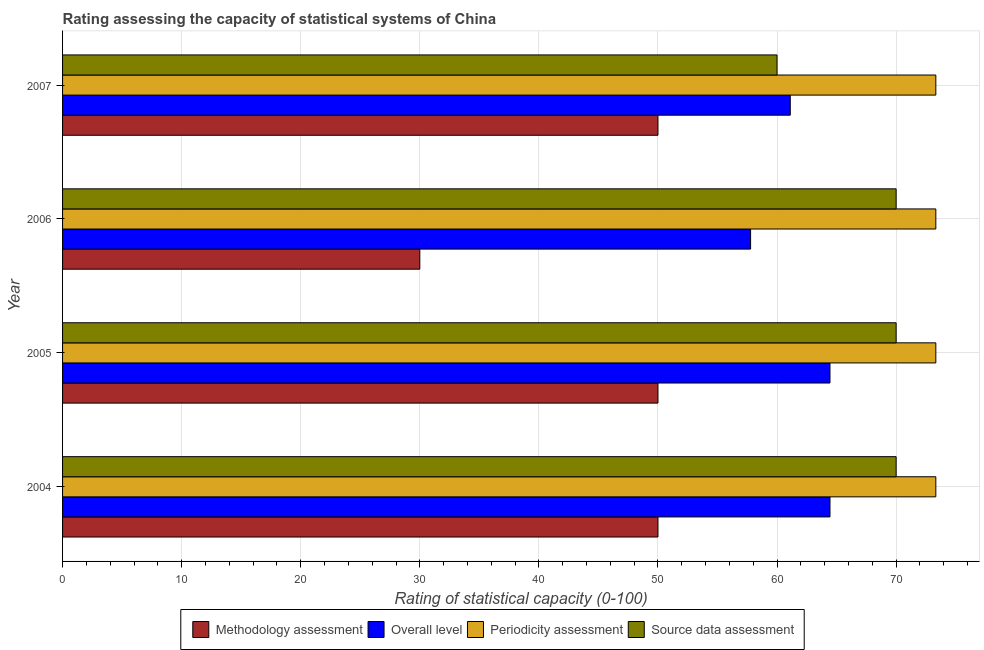How many different coloured bars are there?
Ensure brevity in your answer.  4. How many groups of bars are there?
Offer a very short reply. 4. Are the number of bars on each tick of the Y-axis equal?
Make the answer very short. Yes. How many bars are there on the 1st tick from the top?
Your response must be concise. 4. How many bars are there on the 1st tick from the bottom?
Give a very brief answer. 4. In how many cases, is the number of bars for a given year not equal to the number of legend labels?
Offer a terse response. 0. What is the methodology assessment rating in 2005?
Offer a very short reply. 50. Across all years, what is the maximum overall level rating?
Your answer should be very brief. 64.44. Across all years, what is the minimum source data assessment rating?
Your response must be concise. 60. What is the total overall level rating in the graph?
Provide a succinct answer. 247.78. What is the difference between the overall level rating in 2004 and the source data assessment rating in 2006?
Offer a terse response. -5.56. What is the average overall level rating per year?
Provide a short and direct response. 61.94. In the year 2007, what is the difference between the periodicity assessment rating and source data assessment rating?
Keep it short and to the point. 13.33. What is the ratio of the methodology assessment rating in 2005 to that in 2006?
Provide a short and direct response. 1.67. Is the overall level rating in 2004 less than that in 2007?
Offer a very short reply. No. Is the difference between the source data assessment rating in 2005 and 2006 greater than the difference between the methodology assessment rating in 2005 and 2006?
Make the answer very short. No. What is the difference between the highest and the second highest overall level rating?
Provide a short and direct response. 0. What is the difference between the highest and the lowest methodology assessment rating?
Your answer should be compact. 20. Is the sum of the periodicity assessment rating in 2004 and 2006 greater than the maximum source data assessment rating across all years?
Make the answer very short. Yes. Is it the case that in every year, the sum of the source data assessment rating and overall level rating is greater than the sum of periodicity assessment rating and methodology assessment rating?
Give a very brief answer. Yes. What does the 2nd bar from the top in 2005 represents?
Provide a succinct answer. Periodicity assessment. What does the 3rd bar from the bottom in 2005 represents?
Your answer should be very brief. Periodicity assessment. How many years are there in the graph?
Provide a succinct answer. 4. Are the values on the major ticks of X-axis written in scientific E-notation?
Your answer should be compact. No. Does the graph contain any zero values?
Keep it short and to the point. No. Where does the legend appear in the graph?
Your answer should be very brief. Bottom center. What is the title of the graph?
Offer a terse response. Rating assessing the capacity of statistical systems of China. What is the label or title of the X-axis?
Your answer should be very brief. Rating of statistical capacity (0-100). What is the label or title of the Y-axis?
Give a very brief answer. Year. What is the Rating of statistical capacity (0-100) in Methodology assessment in 2004?
Your answer should be compact. 50. What is the Rating of statistical capacity (0-100) in Overall level in 2004?
Give a very brief answer. 64.44. What is the Rating of statistical capacity (0-100) in Periodicity assessment in 2004?
Provide a succinct answer. 73.33. What is the Rating of statistical capacity (0-100) of Source data assessment in 2004?
Your response must be concise. 70. What is the Rating of statistical capacity (0-100) in Overall level in 2005?
Keep it short and to the point. 64.44. What is the Rating of statistical capacity (0-100) of Periodicity assessment in 2005?
Offer a very short reply. 73.33. What is the Rating of statistical capacity (0-100) of Methodology assessment in 2006?
Give a very brief answer. 30. What is the Rating of statistical capacity (0-100) in Overall level in 2006?
Make the answer very short. 57.78. What is the Rating of statistical capacity (0-100) in Periodicity assessment in 2006?
Keep it short and to the point. 73.33. What is the Rating of statistical capacity (0-100) in Source data assessment in 2006?
Give a very brief answer. 70. What is the Rating of statistical capacity (0-100) in Overall level in 2007?
Make the answer very short. 61.11. What is the Rating of statistical capacity (0-100) of Periodicity assessment in 2007?
Your answer should be compact. 73.33. Across all years, what is the maximum Rating of statistical capacity (0-100) in Methodology assessment?
Give a very brief answer. 50. Across all years, what is the maximum Rating of statistical capacity (0-100) of Overall level?
Your answer should be compact. 64.44. Across all years, what is the maximum Rating of statistical capacity (0-100) in Periodicity assessment?
Provide a short and direct response. 73.33. Across all years, what is the maximum Rating of statistical capacity (0-100) in Source data assessment?
Give a very brief answer. 70. Across all years, what is the minimum Rating of statistical capacity (0-100) of Methodology assessment?
Offer a terse response. 30. Across all years, what is the minimum Rating of statistical capacity (0-100) in Overall level?
Offer a very short reply. 57.78. Across all years, what is the minimum Rating of statistical capacity (0-100) of Periodicity assessment?
Provide a short and direct response. 73.33. What is the total Rating of statistical capacity (0-100) of Methodology assessment in the graph?
Your answer should be very brief. 180. What is the total Rating of statistical capacity (0-100) in Overall level in the graph?
Keep it short and to the point. 247.78. What is the total Rating of statistical capacity (0-100) of Periodicity assessment in the graph?
Provide a succinct answer. 293.33. What is the total Rating of statistical capacity (0-100) of Source data assessment in the graph?
Keep it short and to the point. 270. What is the difference between the Rating of statistical capacity (0-100) in Methodology assessment in 2004 and that in 2005?
Offer a terse response. 0. What is the difference between the Rating of statistical capacity (0-100) of Overall level in 2004 and that in 2005?
Make the answer very short. 0. What is the difference between the Rating of statistical capacity (0-100) of Periodicity assessment in 2004 and that in 2005?
Provide a short and direct response. 0. What is the difference between the Rating of statistical capacity (0-100) in Source data assessment in 2004 and that in 2005?
Offer a very short reply. 0. What is the difference between the Rating of statistical capacity (0-100) in Overall level in 2004 and that in 2006?
Give a very brief answer. 6.67. What is the difference between the Rating of statistical capacity (0-100) of Source data assessment in 2004 and that in 2007?
Your answer should be very brief. 10. What is the difference between the Rating of statistical capacity (0-100) of Methodology assessment in 2005 and that in 2006?
Keep it short and to the point. 20. What is the difference between the Rating of statistical capacity (0-100) in Overall level in 2005 and that in 2006?
Your answer should be very brief. 6.67. What is the difference between the Rating of statistical capacity (0-100) of Source data assessment in 2005 and that in 2006?
Your response must be concise. 0. What is the difference between the Rating of statistical capacity (0-100) in Methodology assessment in 2006 and that in 2007?
Your answer should be compact. -20. What is the difference between the Rating of statistical capacity (0-100) of Overall level in 2006 and that in 2007?
Offer a terse response. -3.33. What is the difference between the Rating of statistical capacity (0-100) in Periodicity assessment in 2006 and that in 2007?
Your answer should be compact. 0. What is the difference between the Rating of statistical capacity (0-100) in Methodology assessment in 2004 and the Rating of statistical capacity (0-100) in Overall level in 2005?
Offer a very short reply. -14.44. What is the difference between the Rating of statistical capacity (0-100) in Methodology assessment in 2004 and the Rating of statistical capacity (0-100) in Periodicity assessment in 2005?
Provide a succinct answer. -23.33. What is the difference between the Rating of statistical capacity (0-100) of Overall level in 2004 and the Rating of statistical capacity (0-100) of Periodicity assessment in 2005?
Give a very brief answer. -8.89. What is the difference between the Rating of statistical capacity (0-100) of Overall level in 2004 and the Rating of statistical capacity (0-100) of Source data assessment in 2005?
Offer a very short reply. -5.56. What is the difference between the Rating of statistical capacity (0-100) in Methodology assessment in 2004 and the Rating of statistical capacity (0-100) in Overall level in 2006?
Offer a very short reply. -7.78. What is the difference between the Rating of statistical capacity (0-100) in Methodology assessment in 2004 and the Rating of statistical capacity (0-100) in Periodicity assessment in 2006?
Your response must be concise. -23.33. What is the difference between the Rating of statistical capacity (0-100) in Overall level in 2004 and the Rating of statistical capacity (0-100) in Periodicity assessment in 2006?
Provide a short and direct response. -8.89. What is the difference between the Rating of statistical capacity (0-100) in Overall level in 2004 and the Rating of statistical capacity (0-100) in Source data assessment in 2006?
Keep it short and to the point. -5.56. What is the difference between the Rating of statistical capacity (0-100) of Periodicity assessment in 2004 and the Rating of statistical capacity (0-100) of Source data assessment in 2006?
Your answer should be very brief. 3.33. What is the difference between the Rating of statistical capacity (0-100) in Methodology assessment in 2004 and the Rating of statistical capacity (0-100) in Overall level in 2007?
Provide a short and direct response. -11.11. What is the difference between the Rating of statistical capacity (0-100) of Methodology assessment in 2004 and the Rating of statistical capacity (0-100) of Periodicity assessment in 2007?
Keep it short and to the point. -23.33. What is the difference between the Rating of statistical capacity (0-100) of Methodology assessment in 2004 and the Rating of statistical capacity (0-100) of Source data assessment in 2007?
Provide a succinct answer. -10. What is the difference between the Rating of statistical capacity (0-100) of Overall level in 2004 and the Rating of statistical capacity (0-100) of Periodicity assessment in 2007?
Offer a terse response. -8.89. What is the difference between the Rating of statistical capacity (0-100) of Overall level in 2004 and the Rating of statistical capacity (0-100) of Source data assessment in 2007?
Make the answer very short. 4.44. What is the difference between the Rating of statistical capacity (0-100) of Periodicity assessment in 2004 and the Rating of statistical capacity (0-100) of Source data assessment in 2007?
Provide a short and direct response. 13.33. What is the difference between the Rating of statistical capacity (0-100) of Methodology assessment in 2005 and the Rating of statistical capacity (0-100) of Overall level in 2006?
Your answer should be very brief. -7.78. What is the difference between the Rating of statistical capacity (0-100) in Methodology assessment in 2005 and the Rating of statistical capacity (0-100) in Periodicity assessment in 2006?
Offer a terse response. -23.33. What is the difference between the Rating of statistical capacity (0-100) of Overall level in 2005 and the Rating of statistical capacity (0-100) of Periodicity assessment in 2006?
Your answer should be very brief. -8.89. What is the difference between the Rating of statistical capacity (0-100) in Overall level in 2005 and the Rating of statistical capacity (0-100) in Source data assessment in 2006?
Ensure brevity in your answer.  -5.56. What is the difference between the Rating of statistical capacity (0-100) of Methodology assessment in 2005 and the Rating of statistical capacity (0-100) of Overall level in 2007?
Keep it short and to the point. -11.11. What is the difference between the Rating of statistical capacity (0-100) in Methodology assessment in 2005 and the Rating of statistical capacity (0-100) in Periodicity assessment in 2007?
Give a very brief answer. -23.33. What is the difference between the Rating of statistical capacity (0-100) in Methodology assessment in 2005 and the Rating of statistical capacity (0-100) in Source data assessment in 2007?
Offer a terse response. -10. What is the difference between the Rating of statistical capacity (0-100) of Overall level in 2005 and the Rating of statistical capacity (0-100) of Periodicity assessment in 2007?
Make the answer very short. -8.89. What is the difference between the Rating of statistical capacity (0-100) of Overall level in 2005 and the Rating of statistical capacity (0-100) of Source data assessment in 2007?
Your answer should be compact. 4.44. What is the difference between the Rating of statistical capacity (0-100) in Periodicity assessment in 2005 and the Rating of statistical capacity (0-100) in Source data assessment in 2007?
Provide a short and direct response. 13.33. What is the difference between the Rating of statistical capacity (0-100) in Methodology assessment in 2006 and the Rating of statistical capacity (0-100) in Overall level in 2007?
Your response must be concise. -31.11. What is the difference between the Rating of statistical capacity (0-100) of Methodology assessment in 2006 and the Rating of statistical capacity (0-100) of Periodicity assessment in 2007?
Make the answer very short. -43.33. What is the difference between the Rating of statistical capacity (0-100) in Overall level in 2006 and the Rating of statistical capacity (0-100) in Periodicity assessment in 2007?
Provide a succinct answer. -15.56. What is the difference between the Rating of statistical capacity (0-100) of Overall level in 2006 and the Rating of statistical capacity (0-100) of Source data assessment in 2007?
Provide a succinct answer. -2.22. What is the difference between the Rating of statistical capacity (0-100) of Periodicity assessment in 2006 and the Rating of statistical capacity (0-100) of Source data assessment in 2007?
Ensure brevity in your answer.  13.33. What is the average Rating of statistical capacity (0-100) of Overall level per year?
Offer a terse response. 61.94. What is the average Rating of statistical capacity (0-100) in Periodicity assessment per year?
Your response must be concise. 73.33. What is the average Rating of statistical capacity (0-100) of Source data assessment per year?
Provide a short and direct response. 67.5. In the year 2004, what is the difference between the Rating of statistical capacity (0-100) of Methodology assessment and Rating of statistical capacity (0-100) of Overall level?
Make the answer very short. -14.44. In the year 2004, what is the difference between the Rating of statistical capacity (0-100) of Methodology assessment and Rating of statistical capacity (0-100) of Periodicity assessment?
Your answer should be very brief. -23.33. In the year 2004, what is the difference between the Rating of statistical capacity (0-100) in Methodology assessment and Rating of statistical capacity (0-100) in Source data assessment?
Your response must be concise. -20. In the year 2004, what is the difference between the Rating of statistical capacity (0-100) in Overall level and Rating of statistical capacity (0-100) in Periodicity assessment?
Give a very brief answer. -8.89. In the year 2004, what is the difference between the Rating of statistical capacity (0-100) in Overall level and Rating of statistical capacity (0-100) in Source data assessment?
Keep it short and to the point. -5.56. In the year 2004, what is the difference between the Rating of statistical capacity (0-100) of Periodicity assessment and Rating of statistical capacity (0-100) of Source data assessment?
Make the answer very short. 3.33. In the year 2005, what is the difference between the Rating of statistical capacity (0-100) of Methodology assessment and Rating of statistical capacity (0-100) of Overall level?
Offer a terse response. -14.44. In the year 2005, what is the difference between the Rating of statistical capacity (0-100) of Methodology assessment and Rating of statistical capacity (0-100) of Periodicity assessment?
Ensure brevity in your answer.  -23.33. In the year 2005, what is the difference between the Rating of statistical capacity (0-100) of Overall level and Rating of statistical capacity (0-100) of Periodicity assessment?
Keep it short and to the point. -8.89. In the year 2005, what is the difference between the Rating of statistical capacity (0-100) in Overall level and Rating of statistical capacity (0-100) in Source data assessment?
Your response must be concise. -5.56. In the year 2005, what is the difference between the Rating of statistical capacity (0-100) of Periodicity assessment and Rating of statistical capacity (0-100) of Source data assessment?
Make the answer very short. 3.33. In the year 2006, what is the difference between the Rating of statistical capacity (0-100) of Methodology assessment and Rating of statistical capacity (0-100) of Overall level?
Keep it short and to the point. -27.78. In the year 2006, what is the difference between the Rating of statistical capacity (0-100) of Methodology assessment and Rating of statistical capacity (0-100) of Periodicity assessment?
Ensure brevity in your answer.  -43.33. In the year 2006, what is the difference between the Rating of statistical capacity (0-100) of Overall level and Rating of statistical capacity (0-100) of Periodicity assessment?
Your response must be concise. -15.56. In the year 2006, what is the difference between the Rating of statistical capacity (0-100) of Overall level and Rating of statistical capacity (0-100) of Source data assessment?
Your response must be concise. -12.22. In the year 2006, what is the difference between the Rating of statistical capacity (0-100) in Periodicity assessment and Rating of statistical capacity (0-100) in Source data assessment?
Your response must be concise. 3.33. In the year 2007, what is the difference between the Rating of statistical capacity (0-100) of Methodology assessment and Rating of statistical capacity (0-100) of Overall level?
Provide a short and direct response. -11.11. In the year 2007, what is the difference between the Rating of statistical capacity (0-100) in Methodology assessment and Rating of statistical capacity (0-100) in Periodicity assessment?
Ensure brevity in your answer.  -23.33. In the year 2007, what is the difference between the Rating of statistical capacity (0-100) in Methodology assessment and Rating of statistical capacity (0-100) in Source data assessment?
Provide a short and direct response. -10. In the year 2007, what is the difference between the Rating of statistical capacity (0-100) in Overall level and Rating of statistical capacity (0-100) in Periodicity assessment?
Your response must be concise. -12.22. In the year 2007, what is the difference between the Rating of statistical capacity (0-100) in Periodicity assessment and Rating of statistical capacity (0-100) in Source data assessment?
Provide a short and direct response. 13.33. What is the ratio of the Rating of statistical capacity (0-100) in Overall level in 2004 to that in 2005?
Offer a terse response. 1. What is the ratio of the Rating of statistical capacity (0-100) in Periodicity assessment in 2004 to that in 2005?
Provide a short and direct response. 1. What is the ratio of the Rating of statistical capacity (0-100) of Methodology assessment in 2004 to that in 2006?
Give a very brief answer. 1.67. What is the ratio of the Rating of statistical capacity (0-100) of Overall level in 2004 to that in 2006?
Provide a short and direct response. 1.12. What is the ratio of the Rating of statistical capacity (0-100) of Overall level in 2004 to that in 2007?
Your answer should be compact. 1.05. What is the ratio of the Rating of statistical capacity (0-100) in Source data assessment in 2004 to that in 2007?
Ensure brevity in your answer.  1.17. What is the ratio of the Rating of statistical capacity (0-100) of Methodology assessment in 2005 to that in 2006?
Your answer should be very brief. 1.67. What is the ratio of the Rating of statistical capacity (0-100) in Overall level in 2005 to that in 2006?
Provide a succinct answer. 1.12. What is the ratio of the Rating of statistical capacity (0-100) of Periodicity assessment in 2005 to that in 2006?
Your answer should be very brief. 1. What is the ratio of the Rating of statistical capacity (0-100) of Source data assessment in 2005 to that in 2006?
Offer a terse response. 1. What is the ratio of the Rating of statistical capacity (0-100) of Overall level in 2005 to that in 2007?
Provide a succinct answer. 1.05. What is the ratio of the Rating of statistical capacity (0-100) in Source data assessment in 2005 to that in 2007?
Offer a terse response. 1.17. What is the ratio of the Rating of statistical capacity (0-100) in Methodology assessment in 2006 to that in 2007?
Offer a terse response. 0.6. What is the ratio of the Rating of statistical capacity (0-100) of Overall level in 2006 to that in 2007?
Your answer should be compact. 0.95. What is the ratio of the Rating of statistical capacity (0-100) of Periodicity assessment in 2006 to that in 2007?
Offer a very short reply. 1. What is the difference between the highest and the second highest Rating of statistical capacity (0-100) in Source data assessment?
Your answer should be compact. 0. What is the difference between the highest and the lowest Rating of statistical capacity (0-100) of Methodology assessment?
Your response must be concise. 20. What is the difference between the highest and the lowest Rating of statistical capacity (0-100) of Overall level?
Your answer should be very brief. 6.67. What is the difference between the highest and the lowest Rating of statistical capacity (0-100) in Source data assessment?
Keep it short and to the point. 10. 